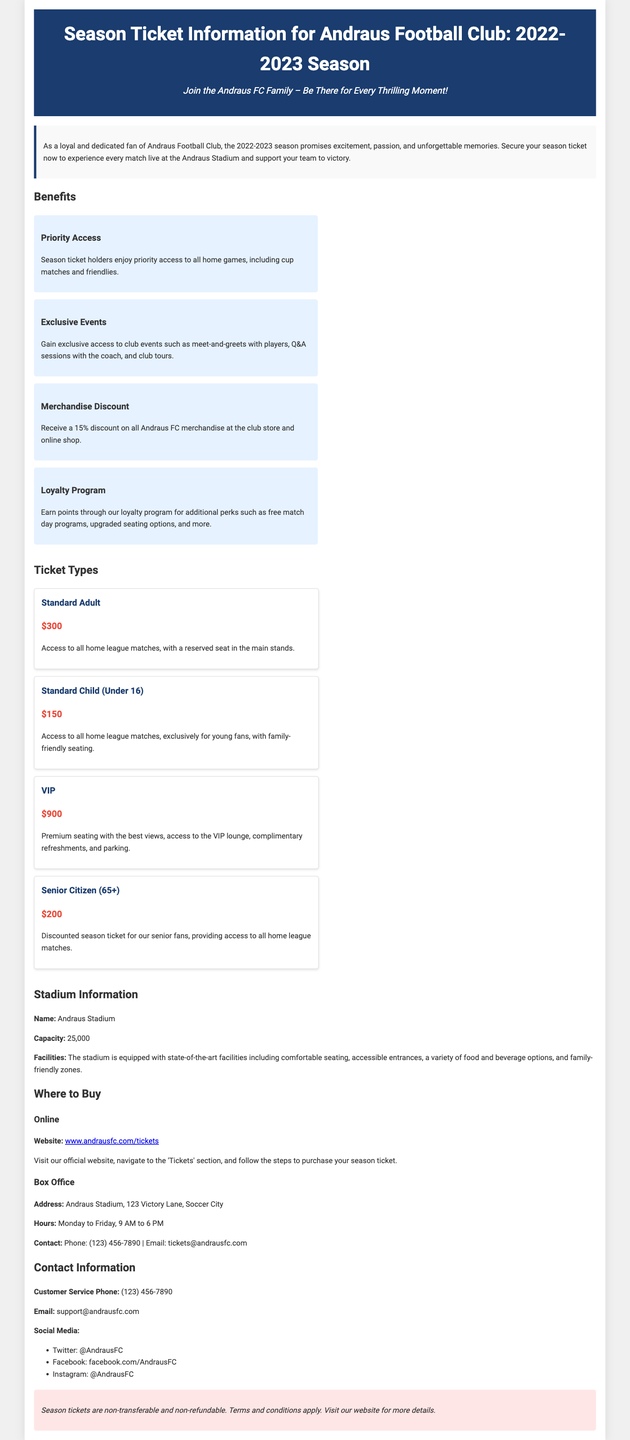What is the price of a Standard Adult season ticket? The price for a Standard Adult season ticket is stated directly in the document.
Answer: $300 What benefits do season ticket holders enjoy? The document lists several benefits available to season ticket holders.
Answer: Priority Access, Exclusive Events, Merchandise Discount, Loyalty Program What is the capacity of the Andraus Stadium? The stadium capacity is clearly mentioned in the stadium information section of the document.
Answer: 25,000 What discount do season ticket holders receive on merchandise? The document specifies the percentage discount applicable to merchandise purchases.
Answer: 15% When can tickets be purchased at the box office? The operational hours for purchasing tickets at the box office are noted in the document.
Answer: Monday to Friday, 9 AM to 6 PM What is the name of the Andraus Football Club's stadium? The document provides the name of the stadium in the stadium information section.
Answer: Andraus Stadium How can one purchase season tickets online? The document instructs readers on how to navigate the website to buy tickets.
Answer: Visit www.andrausfc.com/tickets What is the price of a Senior Citizen season ticket? The document includes the specific price for the Senior Citizen ticket type.
Answer: $200 